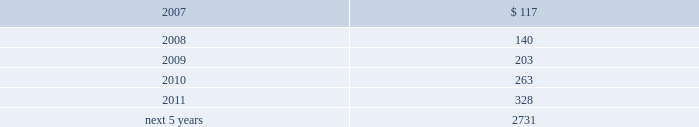The table displays the expected benefit payments in the years indicated : ( dollars in thousands ) .
1 4 .
D i v i d e n d r e s t r i c t i o n s a n d s t a t u t o r y f i n a n c i a l i n f o r m a t i o n a .
D i v i d e n d r e s t r i c t i o n s under bermuda law , group is prohibited from declaring or paying a dividend if such payment would reduce the realizable value of its assets to an amount less than the aggregate value of its liabilities and its issued share capital and share premium ( addi- tional paid-in capital ) accounts .
Group 2019s ability to pay dividends and its operating expenses is dependent upon dividends from its subsidiaries .
The payment of such dividends by insurer subsidiaries is limited under bermuda law and the laws of the var- ious u.s .
States in which group 2019s insurance and reinsurance subsidiaries are domiciled or deemed domiciled .
The limitations are generally based upon net income and compliance with applicable policyholders 2019 surplus or minimum solvency margin and liquidity ratio requirements as determined in accordance with the relevant statutory accounting practices .
Under bermuda law , bermuda re is prohibited from declaring or making payment of a dividend if it fails to meet its minimum solvency margin or minimum liquidity ratio .
As a long-term insurer , bermuda re is also unable to declare or pay a dividend to anyone who is not a policyholder unless , after payment of the dividend , the value of the assets in its long-term business fund , as certified by its approved actuary , exceeds its liabilities for long-term business by at least the $ 250000 minimum solvency margin .
Prior approval of the bermuda monetary authority is required if bermuda re 2019s dividend payments would reduce its prior year-end total statutory capital by 15.0% ( 15.0 % ) or more .
Delaware law provides that an insurance company which is a member of an insurance holding company system and is domi- ciled in the state shall not pay dividends without giving prior notice to the insurance commissioner of delaware and may not pay dividends without the approval of the insurance commissioner if the value of the proposed dividend , together with all other dividends and distributions made in the preceding twelve months , exceeds the greater of ( 1 ) 10% ( 10 % ) of statutory surplus or ( 2 ) net income , not including realized capital gains , each as reported in the prior year 2019s statutory annual statement .
In addition , no dividend may be paid in excess of unassigned earned surplus .
At december 31 , 2006 , everest re had $ 270.4 million available for payment of dividends in 2007 without the need for prior regulatory approval .
S t a t u t o r y f i n a n c i a l i n f o r m a t i o n everest re prepares its statutory financial statements in accordance with accounting practices prescribed or permitted by the national association of insurance commissioners ( 201cnaic 201d ) and the delaware insurance department .
Prescribed statutory accounting practices are set forth in the naic accounting practices and procedures manual .
The capital and statutory surplus of everest re was $ 2704.1 million ( unaudited ) and $ 2327.6 million at december 31 , 2006 and 2005 , respectively .
The statutory net income of everest re was $ 298.7 million ( unaudited ) for the year ended december 31 , 2006 , the statutory net loss was $ 26.9 million for the year ended december 31 , 2005 and the statutory net income $ 175.8 million for the year ended december 31 , 2004 .
Bermuda re prepares its statutory financial statements in conformity with the accounting principles set forth in bermuda in the insurance act 1978 , amendments thereto and related regulations .
The statutory capital and surplus of bermuda re was $ 1893.9 million ( unaudited ) and $ 1522.5 million at december 31 , 2006 and 2005 , respectively .
The statutory net income of bermuda re was $ 409.8 million ( unaudited ) for the year ended december 31 , 2006 , the statutory net loss was $ 220.5 million for the year ended december 31 , 2005 and the statutory net income was $ 248.7 million for the year ended december 31 , 2004 .
1 5 .
C o n t i n g e n c i e s in the ordinary course of business , the company is involved in lawsuits , arbitrations and other formal and informal dispute resolution procedures , the outcomes of which will determine the company 2019s rights and obligations under insurance , reinsur- ance and other contractual agreements .
In some disputes , the company seeks to enforce its rights under an agreement or to collect funds owing to it .
In other matters , the company is resisting attempts by others to collect funds or enforce alleged rights .
These disputes arise from time to time and as they arise are addressed , and ultimately resolved , through both informal and formal means , including negotiated resolution , arbitration and litigation .
In all such matters , the company believes that .
From 2007 to 2011 what was the total expected benefits payments in thousands? 
Computations: ((((117 + 140) + 203) + 263) + 328)
Answer: 1051.0. The table displays the expected benefit payments in the years indicated : ( dollars in thousands ) .
1 4 .
D i v i d e n d r e s t r i c t i o n s a n d s t a t u t o r y f i n a n c i a l i n f o r m a t i o n a .
D i v i d e n d r e s t r i c t i o n s under bermuda law , group is prohibited from declaring or paying a dividend if such payment would reduce the realizable value of its assets to an amount less than the aggregate value of its liabilities and its issued share capital and share premium ( addi- tional paid-in capital ) accounts .
Group 2019s ability to pay dividends and its operating expenses is dependent upon dividends from its subsidiaries .
The payment of such dividends by insurer subsidiaries is limited under bermuda law and the laws of the var- ious u.s .
States in which group 2019s insurance and reinsurance subsidiaries are domiciled or deemed domiciled .
The limitations are generally based upon net income and compliance with applicable policyholders 2019 surplus or minimum solvency margin and liquidity ratio requirements as determined in accordance with the relevant statutory accounting practices .
Under bermuda law , bermuda re is prohibited from declaring or making payment of a dividend if it fails to meet its minimum solvency margin or minimum liquidity ratio .
As a long-term insurer , bermuda re is also unable to declare or pay a dividend to anyone who is not a policyholder unless , after payment of the dividend , the value of the assets in its long-term business fund , as certified by its approved actuary , exceeds its liabilities for long-term business by at least the $ 250000 minimum solvency margin .
Prior approval of the bermuda monetary authority is required if bermuda re 2019s dividend payments would reduce its prior year-end total statutory capital by 15.0% ( 15.0 % ) or more .
Delaware law provides that an insurance company which is a member of an insurance holding company system and is domi- ciled in the state shall not pay dividends without giving prior notice to the insurance commissioner of delaware and may not pay dividends without the approval of the insurance commissioner if the value of the proposed dividend , together with all other dividends and distributions made in the preceding twelve months , exceeds the greater of ( 1 ) 10% ( 10 % ) of statutory surplus or ( 2 ) net income , not including realized capital gains , each as reported in the prior year 2019s statutory annual statement .
In addition , no dividend may be paid in excess of unassigned earned surplus .
At december 31 , 2006 , everest re had $ 270.4 million available for payment of dividends in 2007 without the need for prior regulatory approval .
S t a t u t o r y f i n a n c i a l i n f o r m a t i o n everest re prepares its statutory financial statements in accordance with accounting practices prescribed or permitted by the national association of insurance commissioners ( 201cnaic 201d ) and the delaware insurance department .
Prescribed statutory accounting practices are set forth in the naic accounting practices and procedures manual .
The capital and statutory surplus of everest re was $ 2704.1 million ( unaudited ) and $ 2327.6 million at december 31 , 2006 and 2005 , respectively .
The statutory net income of everest re was $ 298.7 million ( unaudited ) for the year ended december 31 , 2006 , the statutory net loss was $ 26.9 million for the year ended december 31 , 2005 and the statutory net income $ 175.8 million for the year ended december 31 , 2004 .
Bermuda re prepares its statutory financial statements in conformity with the accounting principles set forth in bermuda in the insurance act 1978 , amendments thereto and related regulations .
The statutory capital and surplus of bermuda re was $ 1893.9 million ( unaudited ) and $ 1522.5 million at december 31 , 2006 and 2005 , respectively .
The statutory net income of bermuda re was $ 409.8 million ( unaudited ) for the year ended december 31 , 2006 , the statutory net loss was $ 220.5 million for the year ended december 31 , 2005 and the statutory net income was $ 248.7 million for the year ended december 31 , 2004 .
1 5 .
C o n t i n g e n c i e s in the ordinary course of business , the company is involved in lawsuits , arbitrations and other formal and informal dispute resolution procedures , the outcomes of which will determine the company 2019s rights and obligations under insurance , reinsur- ance and other contractual agreements .
In some disputes , the company seeks to enforce its rights under an agreement or to collect funds owing to it .
In other matters , the company is resisting attempts by others to collect funds or enforce alleged rights .
These disputes arise from time to time and as they arise are addressed , and ultimately resolved , through both informal and formal means , including negotiated resolution , arbitration and litigation .
In all such matters , the company believes that .
What was the percentage change in expected benefits payments from 2009 to 2010? 
Computations: (263 - 203)
Answer: 60.0. 